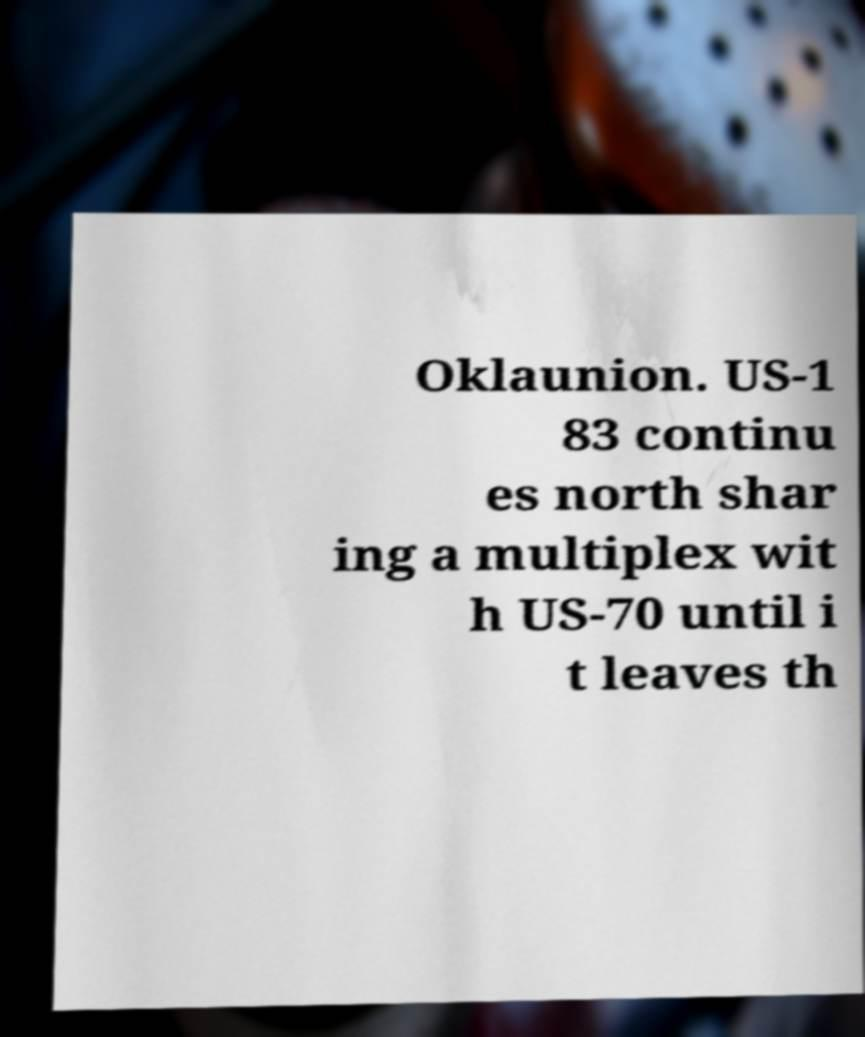Can you read and provide the text displayed in the image?This photo seems to have some interesting text. Can you extract and type it out for me? Oklaunion. US-1 83 continu es north shar ing a multiplex wit h US-70 until i t leaves th 